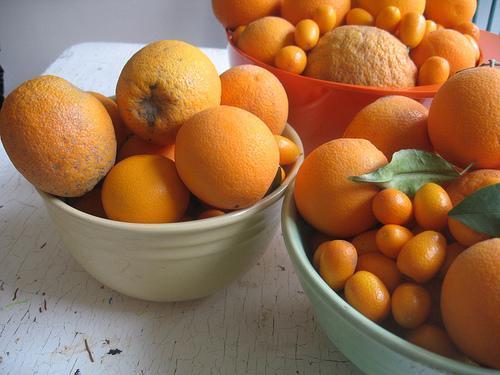How many bowls are there?
Give a very brief answer. 3. How many oranges are in the photo?
Give a very brief answer. 8. How many bowls can be seen?
Give a very brief answer. 3. 